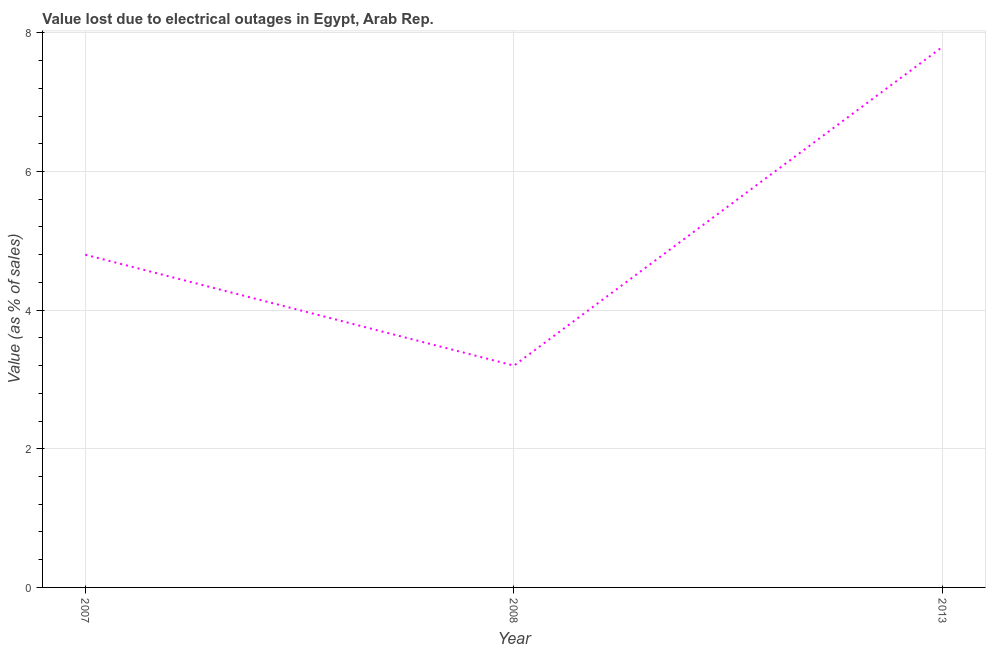What is the value lost due to electrical outages in 2007?
Give a very brief answer. 4.8. Across all years, what is the minimum value lost due to electrical outages?
Provide a succinct answer. 3.2. In which year was the value lost due to electrical outages minimum?
Ensure brevity in your answer.  2008. What is the difference between the value lost due to electrical outages in 2007 and 2013?
Offer a very short reply. -3. What is the average value lost due to electrical outages per year?
Make the answer very short. 5.27. In how many years, is the value lost due to electrical outages greater than 2.4 %?
Your response must be concise. 3. What is the ratio of the value lost due to electrical outages in 2008 to that in 2013?
Make the answer very short. 0.41. Is the value lost due to electrical outages in 2008 less than that in 2013?
Provide a succinct answer. Yes. Is the difference between the value lost due to electrical outages in 2007 and 2008 greater than the difference between any two years?
Provide a short and direct response. No. How many lines are there?
Your response must be concise. 1. How many years are there in the graph?
Ensure brevity in your answer.  3. What is the difference between two consecutive major ticks on the Y-axis?
Provide a succinct answer. 2. Are the values on the major ticks of Y-axis written in scientific E-notation?
Offer a terse response. No. What is the title of the graph?
Your response must be concise. Value lost due to electrical outages in Egypt, Arab Rep. What is the label or title of the X-axis?
Offer a very short reply. Year. What is the label or title of the Y-axis?
Provide a short and direct response. Value (as % of sales). What is the Value (as % of sales) in 2008?
Give a very brief answer. 3.2. What is the difference between the Value (as % of sales) in 2008 and 2013?
Offer a very short reply. -4.6. What is the ratio of the Value (as % of sales) in 2007 to that in 2013?
Your answer should be very brief. 0.61. What is the ratio of the Value (as % of sales) in 2008 to that in 2013?
Offer a very short reply. 0.41. 